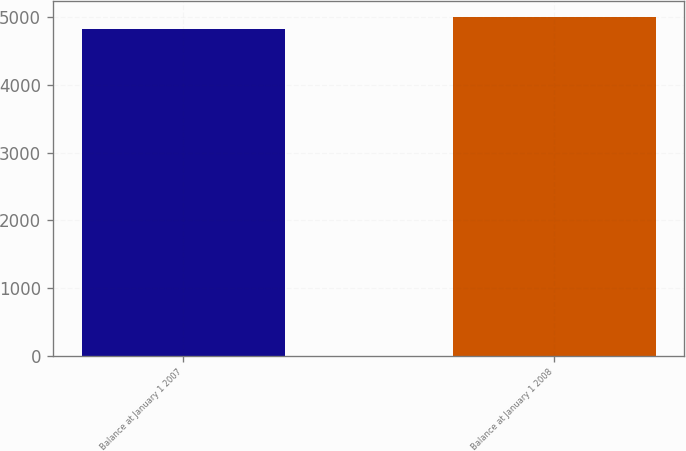<chart> <loc_0><loc_0><loc_500><loc_500><bar_chart><fcel>Balance at January 1 2007<fcel>Balance at January 1 2008<nl><fcel>4829<fcel>4998<nl></chart> 